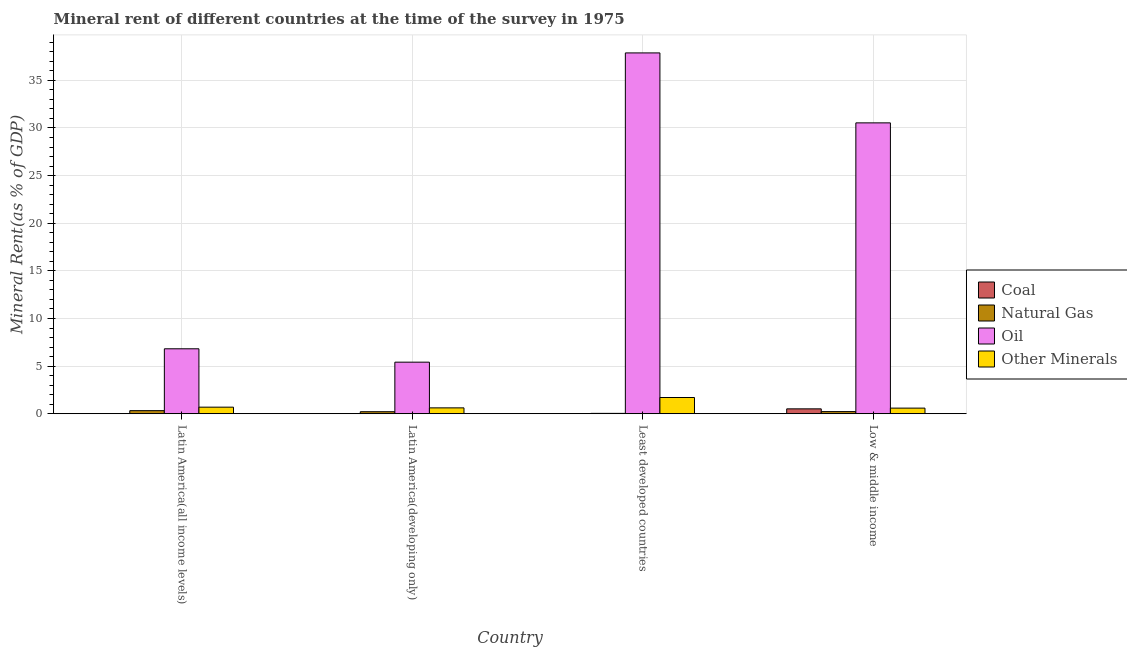Are the number of bars on each tick of the X-axis equal?
Provide a succinct answer. Yes. What is the coal rent in Least developed countries?
Your response must be concise. 0.01. Across all countries, what is the maximum  rent of other minerals?
Give a very brief answer. 1.7. Across all countries, what is the minimum  rent of other minerals?
Offer a terse response. 0.59. In which country was the natural gas rent maximum?
Your answer should be compact. Latin America(all income levels). In which country was the oil rent minimum?
Offer a terse response. Latin America(developing only). What is the total  rent of other minerals in the graph?
Provide a short and direct response. 3.6. What is the difference between the  rent of other minerals in Latin America(developing only) and that in Low & middle income?
Your answer should be compact. 0.03. What is the difference between the oil rent in Latin America(all income levels) and the natural gas rent in Low & middle income?
Your response must be concise. 6.6. What is the average natural gas rent per country?
Provide a succinct answer. 0.2. What is the difference between the oil rent and coal rent in Least developed countries?
Make the answer very short. 37.87. What is the ratio of the natural gas rent in Latin America(developing only) to that in Least developed countries?
Provide a short and direct response. 5.39. Is the natural gas rent in Latin America(all income levels) less than that in Low & middle income?
Your answer should be compact. No. Is the difference between the oil rent in Least developed countries and Low & middle income greater than the difference between the  rent of other minerals in Least developed countries and Low & middle income?
Give a very brief answer. Yes. What is the difference between the highest and the second highest coal rent?
Your answer should be very brief. 0.5. What is the difference between the highest and the lowest natural gas rent?
Ensure brevity in your answer.  0.29. Is the sum of the coal rent in Latin America(all income levels) and Latin America(developing only) greater than the maximum oil rent across all countries?
Your response must be concise. No. What does the 4th bar from the left in Latin America(developing only) represents?
Your answer should be very brief. Other Minerals. What does the 4th bar from the right in Latin America(developing only) represents?
Your answer should be compact. Coal. Is it the case that in every country, the sum of the coal rent and natural gas rent is greater than the oil rent?
Ensure brevity in your answer.  No. Are all the bars in the graph horizontal?
Your response must be concise. No. Are the values on the major ticks of Y-axis written in scientific E-notation?
Your answer should be very brief. No. Does the graph contain any zero values?
Your answer should be very brief. No. Where does the legend appear in the graph?
Your answer should be compact. Center right. How many legend labels are there?
Give a very brief answer. 4. How are the legend labels stacked?
Provide a short and direct response. Vertical. What is the title of the graph?
Provide a succinct answer. Mineral rent of different countries at the time of the survey in 1975. What is the label or title of the Y-axis?
Give a very brief answer. Mineral Rent(as % of GDP). What is the Mineral Rent(as % of GDP) of Coal in Latin America(all income levels)?
Keep it short and to the point. 0.01. What is the Mineral Rent(as % of GDP) of Natural Gas in Latin America(all income levels)?
Provide a succinct answer. 0.33. What is the Mineral Rent(as % of GDP) of Oil in Latin America(all income levels)?
Provide a short and direct response. 6.82. What is the Mineral Rent(as % of GDP) in Other Minerals in Latin America(all income levels)?
Keep it short and to the point. 0.69. What is the Mineral Rent(as % of GDP) of Coal in Latin America(developing only)?
Provide a succinct answer. 0.01. What is the Mineral Rent(as % of GDP) in Natural Gas in Latin America(developing only)?
Make the answer very short. 0.21. What is the Mineral Rent(as % of GDP) of Oil in Latin America(developing only)?
Give a very brief answer. 5.41. What is the Mineral Rent(as % of GDP) in Other Minerals in Latin America(developing only)?
Offer a very short reply. 0.62. What is the Mineral Rent(as % of GDP) of Coal in Least developed countries?
Keep it short and to the point. 0.01. What is the Mineral Rent(as % of GDP) in Natural Gas in Least developed countries?
Provide a short and direct response. 0.04. What is the Mineral Rent(as % of GDP) in Oil in Least developed countries?
Provide a short and direct response. 37.88. What is the Mineral Rent(as % of GDP) of Other Minerals in Least developed countries?
Offer a very short reply. 1.7. What is the Mineral Rent(as % of GDP) in Coal in Low & middle income?
Offer a terse response. 0.51. What is the Mineral Rent(as % of GDP) in Natural Gas in Low & middle income?
Keep it short and to the point. 0.22. What is the Mineral Rent(as % of GDP) in Oil in Low & middle income?
Keep it short and to the point. 30.54. What is the Mineral Rent(as % of GDP) in Other Minerals in Low & middle income?
Your answer should be very brief. 0.59. Across all countries, what is the maximum Mineral Rent(as % of GDP) in Coal?
Your response must be concise. 0.51. Across all countries, what is the maximum Mineral Rent(as % of GDP) of Natural Gas?
Offer a terse response. 0.33. Across all countries, what is the maximum Mineral Rent(as % of GDP) of Oil?
Provide a short and direct response. 37.88. Across all countries, what is the maximum Mineral Rent(as % of GDP) in Other Minerals?
Provide a succinct answer. 1.7. Across all countries, what is the minimum Mineral Rent(as % of GDP) in Coal?
Your answer should be very brief. 0.01. Across all countries, what is the minimum Mineral Rent(as % of GDP) of Natural Gas?
Provide a succinct answer. 0.04. Across all countries, what is the minimum Mineral Rent(as % of GDP) in Oil?
Keep it short and to the point. 5.41. Across all countries, what is the minimum Mineral Rent(as % of GDP) of Other Minerals?
Keep it short and to the point. 0.59. What is the total Mineral Rent(as % of GDP) of Coal in the graph?
Your response must be concise. 0.55. What is the total Mineral Rent(as % of GDP) of Natural Gas in the graph?
Ensure brevity in your answer.  0.8. What is the total Mineral Rent(as % of GDP) in Oil in the graph?
Your answer should be compact. 80.65. What is the total Mineral Rent(as % of GDP) of Other Minerals in the graph?
Offer a very short reply. 3.6. What is the difference between the Mineral Rent(as % of GDP) in Coal in Latin America(all income levels) and that in Latin America(developing only)?
Provide a short and direct response. -0. What is the difference between the Mineral Rent(as % of GDP) in Natural Gas in Latin America(all income levels) and that in Latin America(developing only)?
Ensure brevity in your answer.  0.11. What is the difference between the Mineral Rent(as % of GDP) in Oil in Latin America(all income levels) and that in Latin America(developing only)?
Make the answer very short. 1.41. What is the difference between the Mineral Rent(as % of GDP) in Other Minerals in Latin America(all income levels) and that in Latin America(developing only)?
Offer a terse response. 0.07. What is the difference between the Mineral Rent(as % of GDP) in Coal in Latin America(all income levels) and that in Least developed countries?
Your answer should be compact. 0. What is the difference between the Mineral Rent(as % of GDP) of Natural Gas in Latin America(all income levels) and that in Least developed countries?
Provide a short and direct response. 0.29. What is the difference between the Mineral Rent(as % of GDP) in Oil in Latin America(all income levels) and that in Least developed countries?
Ensure brevity in your answer.  -31.06. What is the difference between the Mineral Rent(as % of GDP) in Other Minerals in Latin America(all income levels) and that in Least developed countries?
Ensure brevity in your answer.  -1.01. What is the difference between the Mineral Rent(as % of GDP) of Coal in Latin America(all income levels) and that in Low & middle income?
Your answer should be compact. -0.5. What is the difference between the Mineral Rent(as % of GDP) of Natural Gas in Latin America(all income levels) and that in Low & middle income?
Offer a terse response. 0.1. What is the difference between the Mineral Rent(as % of GDP) of Oil in Latin America(all income levels) and that in Low & middle income?
Give a very brief answer. -23.72. What is the difference between the Mineral Rent(as % of GDP) in Other Minerals in Latin America(all income levels) and that in Low & middle income?
Provide a succinct answer. 0.1. What is the difference between the Mineral Rent(as % of GDP) in Coal in Latin America(developing only) and that in Least developed countries?
Your response must be concise. 0. What is the difference between the Mineral Rent(as % of GDP) of Natural Gas in Latin America(developing only) and that in Least developed countries?
Keep it short and to the point. 0.17. What is the difference between the Mineral Rent(as % of GDP) in Oil in Latin America(developing only) and that in Least developed countries?
Provide a succinct answer. -32.47. What is the difference between the Mineral Rent(as % of GDP) of Other Minerals in Latin America(developing only) and that in Least developed countries?
Ensure brevity in your answer.  -1.09. What is the difference between the Mineral Rent(as % of GDP) of Coal in Latin America(developing only) and that in Low & middle income?
Provide a succinct answer. -0.5. What is the difference between the Mineral Rent(as % of GDP) of Natural Gas in Latin America(developing only) and that in Low & middle income?
Make the answer very short. -0.01. What is the difference between the Mineral Rent(as % of GDP) in Oil in Latin America(developing only) and that in Low & middle income?
Give a very brief answer. -25.12. What is the difference between the Mineral Rent(as % of GDP) of Other Minerals in Latin America(developing only) and that in Low & middle income?
Keep it short and to the point. 0.03. What is the difference between the Mineral Rent(as % of GDP) of Coal in Least developed countries and that in Low & middle income?
Ensure brevity in your answer.  -0.5. What is the difference between the Mineral Rent(as % of GDP) of Natural Gas in Least developed countries and that in Low & middle income?
Give a very brief answer. -0.18. What is the difference between the Mineral Rent(as % of GDP) of Oil in Least developed countries and that in Low & middle income?
Your answer should be very brief. 7.34. What is the difference between the Mineral Rent(as % of GDP) of Other Minerals in Least developed countries and that in Low & middle income?
Offer a terse response. 1.11. What is the difference between the Mineral Rent(as % of GDP) in Coal in Latin America(all income levels) and the Mineral Rent(as % of GDP) in Natural Gas in Latin America(developing only)?
Your answer should be compact. -0.2. What is the difference between the Mineral Rent(as % of GDP) in Coal in Latin America(all income levels) and the Mineral Rent(as % of GDP) in Oil in Latin America(developing only)?
Provide a short and direct response. -5.4. What is the difference between the Mineral Rent(as % of GDP) of Coal in Latin America(all income levels) and the Mineral Rent(as % of GDP) of Other Minerals in Latin America(developing only)?
Your response must be concise. -0.6. What is the difference between the Mineral Rent(as % of GDP) in Natural Gas in Latin America(all income levels) and the Mineral Rent(as % of GDP) in Oil in Latin America(developing only)?
Your answer should be very brief. -5.09. What is the difference between the Mineral Rent(as % of GDP) in Natural Gas in Latin America(all income levels) and the Mineral Rent(as % of GDP) in Other Minerals in Latin America(developing only)?
Offer a terse response. -0.29. What is the difference between the Mineral Rent(as % of GDP) of Oil in Latin America(all income levels) and the Mineral Rent(as % of GDP) of Other Minerals in Latin America(developing only)?
Provide a short and direct response. 6.2. What is the difference between the Mineral Rent(as % of GDP) in Coal in Latin America(all income levels) and the Mineral Rent(as % of GDP) in Natural Gas in Least developed countries?
Your response must be concise. -0.03. What is the difference between the Mineral Rent(as % of GDP) in Coal in Latin America(all income levels) and the Mineral Rent(as % of GDP) in Oil in Least developed countries?
Your response must be concise. -37.87. What is the difference between the Mineral Rent(as % of GDP) in Coal in Latin America(all income levels) and the Mineral Rent(as % of GDP) in Other Minerals in Least developed countries?
Your answer should be very brief. -1.69. What is the difference between the Mineral Rent(as % of GDP) in Natural Gas in Latin America(all income levels) and the Mineral Rent(as % of GDP) in Oil in Least developed countries?
Give a very brief answer. -37.56. What is the difference between the Mineral Rent(as % of GDP) of Natural Gas in Latin America(all income levels) and the Mineral Rent(as % of GDP) of Other Minerals in Least developed countries?
Your response must be concise. -1.38. What is the difference between the Mineral Rent(as % of GDP) of Oil in Latin America(all income levels) and the Mineral Rent(as % of GDP) of Other Minerals in Least developed countries?
Your answer should be compact. 5.11. What is the difference between the Mineral Rent(as % of GDP) in Coal in Latin America(all income levels) and the Mineral Rent(as % of GDP) in Natural Gas in Low & middle income?
Provide a succinct answer. -0.21. What is the difference between the Mineral Rent(as % of GDP) of Coal in Latin America(all income levels) and the Mineral Rent(as % of GDP) of Oil in Low & middle income?
Provide a succinct answer. -30.53. What is the difference between the Mineral Rent(as % of GDP) of Coal in Latin America(all income levels) and the Mineral Rent(as % of GDP) of Other Minerals in Low & middle income?
Your response must be concise. -0.58. What is the difference between the Mineral Rent(as % of GDP) of Natural Gas in Latin America(all income levels) and the Mineral Rent(as % of GDP) of Oil in Low & middle income?
Keep it short and to the point. -30.21. What is the difference between the Mineral Rent(as % of GDP) in Natural Gas in Latin America(all income levels) and the Mineral Rent(as % of GDP) in Other Minerals in Low & middle income?
Keep it short and to the point. -0.26. What is the difference between the Mineral Rent(as % of GDP) in Oil in Latin America(all income levels) and the Mineral Rent(as % of GDP) in Other Minerals in Low & middle income?
Your answer should be very brief. 6.23. What is the difference between the Mineral Rent(as % of GDP) in Coal in Latin America(developing only) and the Mineral Rent(as % of GDP) in Natural Gas in Least developed countries?
Offer a terse response. -0.02. What is the difference between the Mineral Rent(as % of GDP) in Coal in Latin America(developing only) and the Mineral Rent(as % of GDP) in Oil in Least developed countries?
Provide a succinct answer. -37.87. What is the difference between the Mineral Rent(as % of GDP) in Coal in Latin America(developing only) and the Mineral Rent(as % of GDP) in Other Minerals in Least developed countries?
Your response must be concise. -1.69. What is the difference between the Mineral Rent(as % of GDP) of Natural Gas in Latin America(developing only) and the Mineral Rent(as % of GDP) of Oil in Least developed countries?
Your answer should be compact. -37.67. What is the difference between the Mineral Rent(as % of GDP) of Natural Gas in Latin America(developing only) and the Mineral Rent(as % of GDP) of Other Minerals in Least developed countries?
Give a very brief answer. -1.49. What is the difference between the Mineral Rent(as % of GDP) in Oil in Latin America(developing only) and the Mineral Rent(as % of GDP) in Other Minerals in Least developed countries?
Give a very brief answer. 3.71. What is the difference between the Mineral Rent(as % of GDP) of Coal in Latin America(developing only) and the Mineral Rent(as % of GDP) of Natural Gas in Low & middle income?
Offer a terse response. -0.21. What is the difference between the Mineral Rent(as % of GDP) of Coal in Latin America(developing only) and the Mineral Rent(as % of GDP) of Oil in Low & middle income?
Provide a succinct answer. -30.52. What is the difference between the Mineral Rent(as % of GDP) of Coal in Latin America(developing only) and the Mineral Rent(as % of GDP) of Other Minerals in Low & middle income?
Provide a succinct answer. -0.58. What is the difference between the Mineral Rent(as % of GDP) of Natural Gas in Latin America(developing only) and the Mineral Rent(as % of GDP) of Oil in Low & middle income?
Ensure brevity in your answer.  -30.33. What is the difference between the Mineral Rent(as % of GDP) in Natural Gas in Latin America(developing only) and the Mineral Rent(as % of GDP) in Other Minerals in Low & middle income?
Offer a terse response. -0.38. What is the difference between the Mineral Rent(as % of GDP) of Oil in Latin America(developing only) and the Mineral Rent(as % of GDP) of Other Minerals in Low & middle income?
Your answer should be very brief. 4.82. What is the difference between the Mineral Rent(as % of GDP) of Coal in Least developed countries and the Mineral Rent(as % of GDP) of Natural Gas in Low & middle income?
Your response must be concise. -0.21. What is the difference between the Mineral Rent(as % of GDP) of Coal in Least developed countries and the Mineral Rent(as % of GDP) of Oil in Low & middle income?
Keep it short and to the point. -30.53. What is the difference between the Mineral Rent(as % of GDP) in Coal in Least developed countries and the Mineral Rent(as % of GDP) in Other Minerals in Low & middle income?
Make the answer very short. -0.58. What is the difference between the Mineral Rent(as % of GDP) of Natural Gas in Least developed countries and the Mineral Rent(as % of GDP) of Oil in Low & middle income?
Your answer should be very brief. -30.5. What is the difference between the Mineral Rent(as % of GDP) of Natural Gas in Least developed countries and the Mineral Rent(as % of GDP) of Other Minerals in Low & middle income?
Ensure brevity in your answer.  -0.55. What is the difference between the Mineral Rent(as % of GDP) in Oil in Least developed countries and the Mineral Rent(as % of GDP) in Other Minerals in Low & middle income?
Offer a very short reply. 37.29. What is the average Mineral Rent(as % of GDP) in Coal per country?
Your response must be concise. 0.14. What is the average Mineral Rent(as % of GDP) of Natural Gas per country?
Provide a short and direct response. 0.2. What is the average Mineral Rent(as % of GDP) in Oil per country?
Offer a very short reply. 20.16. What is the average Mineral Rent(as % of GDP) in Other Minerals per country?
Provide a short and direct response. 0.9. What is the difference between the Mineral Rent(as % of GDP) of Coal and Mineral Rent(as % of GDP) of Natural Gas in Latin America(all income levels)?
Make the answer very short. -0.31. What is the difference between the Mineral Rent(as % of GDP) in Coal and Mineral Rent(as % of GDP) in Oil in Latin America(all income levels)?
Keep it short and to the point. -6.81. What is the difference between the Mineral Rent(as % of GDP) of Coal and Mineral Rent(as % of GDP) of Other Minerals in Latin America(all income levels)?
Provide a succinct answer. -0.68. What is the difference between the Mineral Rent(as % of GDP) of Natural Gas and Mineral Rent(as % of GDP) of Oil in Latin America(all income levels)?
Your answer should be compact. -6.49. What is the difference between the Mineral Rent(as % of GDP) of Natural Gas and Mineral Rent(as % of GDP) of Other Minerals in Latin America(all income levels)?
Ensure brevity in your answer.  -0.36. What is the difference between the Mineral Rent(as % of GDP) in Oil and Mineral Rent(as % of GDP) in Other Minerals in Latin America(all income levels)?
Your answer should be very brief. 6.13. What is the difference between the Mineral Rent(as % of GDP) of Coal and Mineral Rent(as % of GDP) of Natural Gas in Latin America(developing only)?
Provide a short and direct response. -0.2. What is the difference between the Mineral Rent(as % of GDP) in Coal and Mineral Rent(as % of GDP) in Oil in Latin America(developing only)?
Make the answer very short. -5.4. What is the difference between the Mineral Rent(as % of GDP) of Coal and Mineral Rent(as % of GDP) of Other Minerals in Latin America(developing only)?
Keep it short and to the point. -0.6. What is the difference between the Mineral Rent(as % of GDP) of Natural Gas and Mineral Rent(as % of GDP) of Oil in Latin America(developing only)?
Make the answer very short. -5.2. What is the difference between the Mineral Rent(as % of GDP) in Natural Gas and Mineral Rent(as % of GDP) in Other Minerals in Latin America(developing only)?
Your answer should be very brief. -0.4. What is the difference between the Mineral Rent(as % of GDP) in Oil and Mineral Rent(as % of GDP) in Other Minerals in Latin America(developing only)?
Provide a short and direct response. 4.8. What is the difference between the Mineral Rent(as % of GDP) in Coal and Mineral Rent(as % of GDP) in Natural Gas in Least developed countries?
Keep it short and to the point. -0.03. What is the difference between the Mineral Rent(as % of GDP) in Coal and Mineral Rent(as % of GDP) in Oil in Least developed countries?
Make the answer very short. -37.87. What is the difference between the Mineral Rent(as % of GDP) in Coal and Mineral Rent(as % of GDP) in Other Minerals in Least developed countries?
Your answer should be very brief. -1.69. What is the difference between the Mineral Rent(as % of GDP) in Natural Gas and Mineral Rent(as % of GDP) in Oil in Least developed countries?
Offer a terse response. -37.84. What is the difference between the Mineral Rent(as % of GDP) in Natural Gas and Mineral Rent(as % of GDP) in Other Minerals in Least developed countries?
Ensure brevity in your answer.  -1.67. What is the difference between the Mineral Rent(as % of GDP) in Oil and Mineral Rent(as % of GDP) in Other Minerals in Least developed countries?
Your answer should be compact. 36.18. What is the difference between the Mineral Rent(as % of GDP) in Coal and Mineral Rent(as % of GDP) in Natural Gas in Low & middle income?
Your answer should be compact. 0.29. What is the difference between the Mineral Rent(as % of GDP) of Coal and Mineral Rent(as % of GDP) of Oil in Low & middle income?
Make the answer very short. -30.02. What is the difference between the Mineral Rent(as % of GDP) of Coal and Mineral Rent(as % of GDP) of Other Minerals in Low & middle income?
Your answer should be very brief. -0.08. What is the difference between the Mineral Rent(as % of GDP) in Natural Gas and Mineral Rent(as % of GDP) in Oil in Low & middle income?
Give a very brief answer. -30.31. What is the difference between the Mineral Rent(as % of GDP) of Natural Gas and Mineral Rent(as % of GDP) of Other Minerals in Low & middle income?
Your answer should be very brief. -0.37. What is the difference between the Mineral Rent(as % of GDP) in Oil and Mineral Rent(as % of GDP) in Other Minerals in Low & middle income?
Your answer should be very brief. 29.95. What is the ratio of the Mineral Rent(as % of GDP) of Coal in Latin America(all income levels) to that in Latin America(developing only)?
Your answer should be very brief. 0.85. What is the ratio of the Mineral Rent(as % of GDP) of Natural Gas in Latin America(all income levels) to that in Latin America(developing only)?
Give a very brief answer. 1.53. What is the ratio of the Mineral Rent(as % of GDP) in Oil in Latin America(all income levels) to that in Latin America(developing only)?
Your answer should be compact. 1.26. What is the ratio of the Mineral Rent(as % of GDP) of Other Minerals in Latin America(all income levels) to that in Latin America(developing only)?
Offer a terse response. 1.12. What is the ratio of the Mineral Rent(as % of GDP) in Coal in Latin America(all income levels) to that in Least developed countries?
Offer a very short reply. 1.04. What is the ratio of the Mineral Rent(as % of GDP) of Natural Gas in Latin America(all income levels) to that in Least developed countries?
Keep it short and to the point. 8.25. What is the ratio of the Mineral Rent(as % of GDP) in Oil in Latin America(all income levels) to that in Least developed countries?
Ensure brevity in your answer.  0.18. What is the ratio of the Mineral Rent(as % of GDP) in Other Minerals in Latin America(all income levels) to that in Least developed countries?
Make the answer very short. 0.4. What is the ratio of the Mineral Rent(as % of GDP) of Coal in Latin America(all income levels) to that in Low & middle income?
Your answer should be very brief. 0.02. What is the ratio of the Mineral Rent(as % of GDP) in Natural Gas in Latin America(all income levels) to that in Low & middle income?
Your response must be concise. 1.45. What is the ratio of the Mineral Rent(as % of GDP) of Oil in Latin America(all income levels) to that in Low & middle income?
Provide a succinct answer. 0.22. What is the ratio of the Mineral Rent(as % of GDP) of Other Minerals in Latin America(all income levels) to that in Low & middle income?
Keep it short and to the point. 1.17. What is the ratio of the Mineral Rent(as % of GDP) of Coal in Latin America(developing only) to that in Least developed countries?
Provide a succinct answer. 1.22. What is the ratio of the Mineral Rent(as % of GDP) of Natural Gas in Latin America(developing only) to that in Least developed countries?
Make the answer very short. 5.39. What is the ratio of the Mineral Rent(as % of GDP) in Oil in Latin America(developing only) to that in Least developed countries?
Your answer should be compact. 0.14. What is the ratio of the Mineral Rent(as % of GDP) in Other Minerals in Latin America(developing only) to that in Least developed countries?
Give a very brief answer. 0.36. What is the ratio of the Mineral Rent(as % of GDP) in Coal in Latin America(developing only) to that in Low & middle income?
Give a very brief answer. 0.03. What is the ratio of the Mineral Rent(as % of GDP) in Natural Gas in Latin America(developing only) to that in Low & middle income?
Offer a terse response. 0.95. What is the ratio of the Mineral Rent(as % of GDP) in Oil in Latin America(developing only) to that in Low & middle income?
Provide a succinct answer. 0.18. What is the ratio of the Mineral Rent(as % of GDP) of Other Minerals in Latin America(developing only) to that in Low & middle income?
Offer a terse response. 1.04. What is the ratio of the Mineral Rent(as % of GDP) in Coal in Least developed countries to that in Low & middle income?
Offer a very short reply. 0.02. What is the ratio of the Mineral Rent(as % of GDP) in Natural Gas in Least developed countries to that in Low & middle income?
Provide a succinct answer. 0.18. What is the ratio of the Mineral Rent(as % of GDP) of Oil in Least developed countries to that in Low & middle income?
Provide a short and direct response. 1.24. What is the ratio of the Mineral Rent(as % of GDP) of Other Minerals in Least developed countries to that in Low & middle income?
Make the answer very short. 2.89. What is the difference between the highest and the second highest Mineral Rent(as % of GDP) of Coal?
Your response must be concise. 0.5. What is the difference between the highest and the second highest Mineral Rent(as % of GDP) in Natural Gas?
Offer a terse response. 0.1. What is the difference between the highest and the second highest Mineral Rent(as % of GDP) of Oil?
Offer a terse response. 7.34. What is the difference between the highest and the second highest Mineral Rent(as % of GDP) in Other Minerals?
Your answer should be compact. 1.01. What is the difference between the highest and the lowest Mineral Rent(as % of GDP) of Coal?
Keep it short and to the point. 0.5. What is the difference between the highest and the lowest Mineral Rent(as % of GDP) in Natural Gas?
Give a very brief answer. 0.29. What is the difference between the highest and the lowest Mineral Rent(as % of GDP) in Oil?
Ensure brevity in your answer.  32.47. What is the difference between the highest and the lowest Mineral Rent(as % of GDP) in Other Minerals?
Offer a terse response. 1.11. 